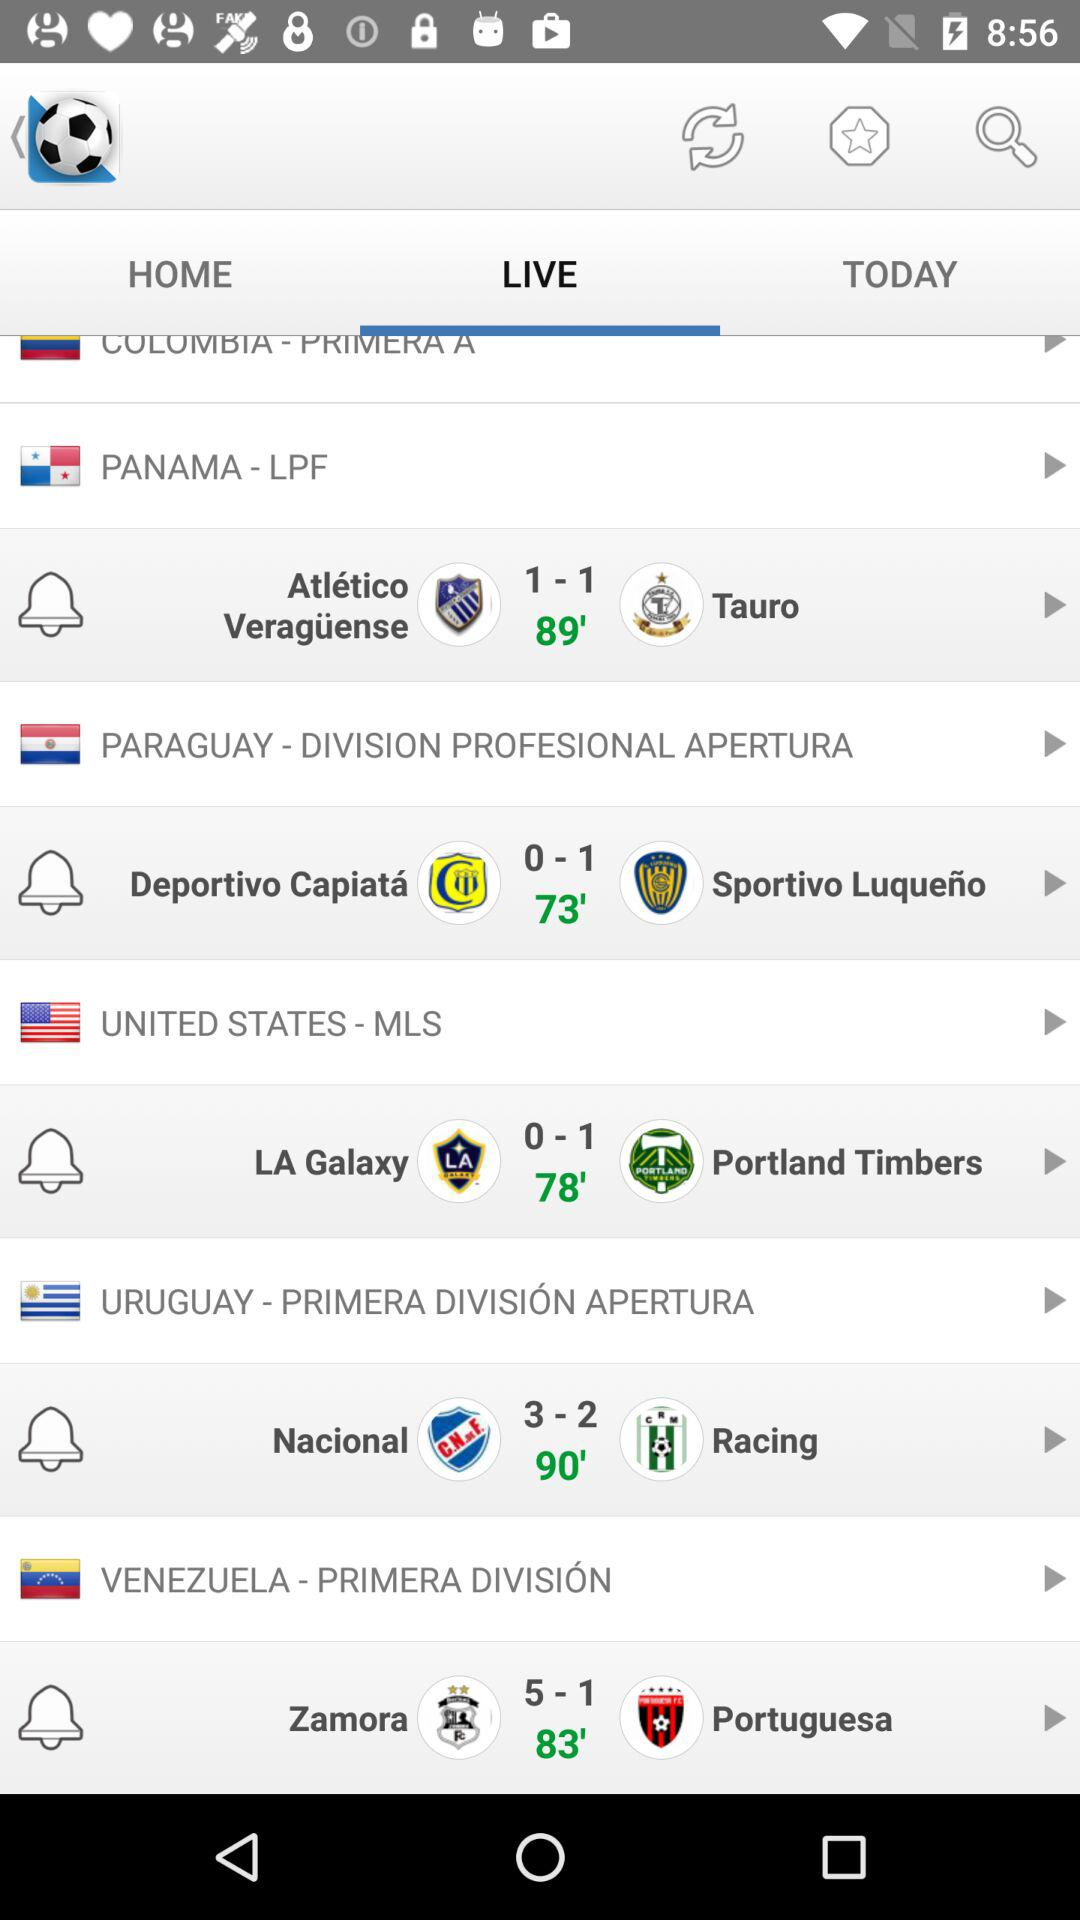What's the score between "LA Galaxy" and "Portland Timbers"? The scores between "LA Galaxy" and "Portland Timbers" are 0 and 1 respectively. 